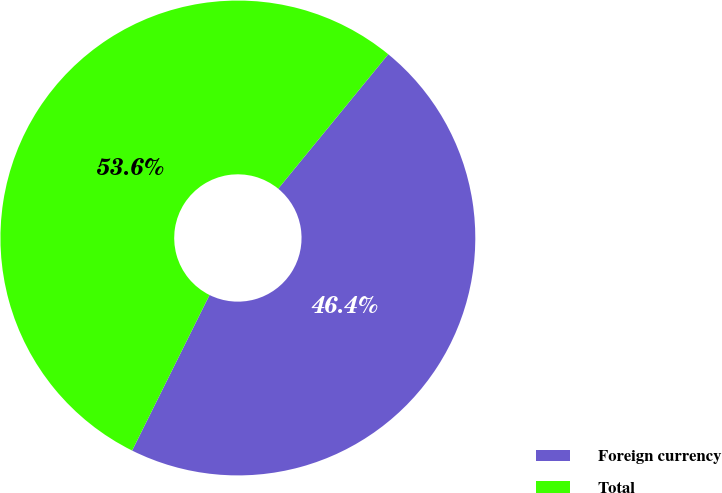Convert chart. <chart><loc_0><loc_0><loc_500><loc_500><pie_chart><fcel>Foreign currency<fcel>Total<nl><fcel>46.43%<fcel>53.57%<nl></chart> 